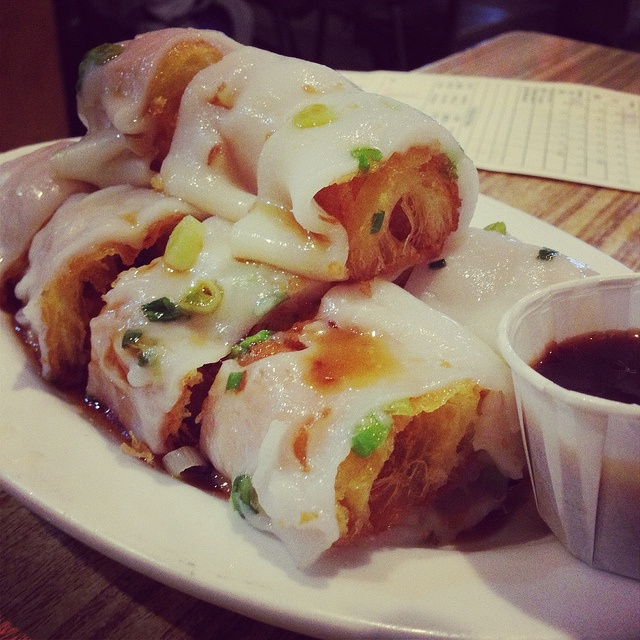Describe the objects in this image and their specific colors. I can see sandwich in black, tan, maroon, and brown tones, dining table in black, beige, maroon, and brown tones, cup in black, darkgray, brown, gray, and purple tones, and hot dog in black, maroon, and brown tones in this image. 